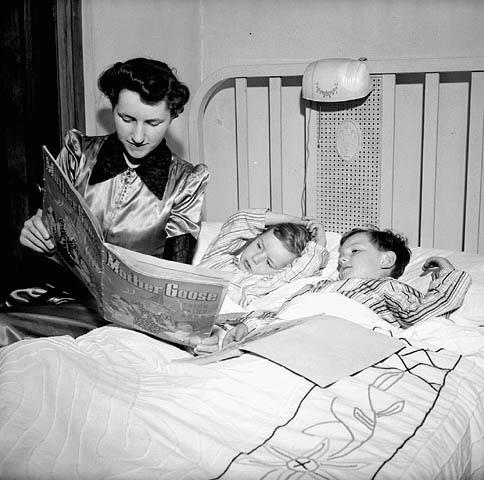Why is this book appropriate for her to read?

Choices:
A) school book
B) nursery rhymes
C) romance novel
D) bible nursery rhymes 